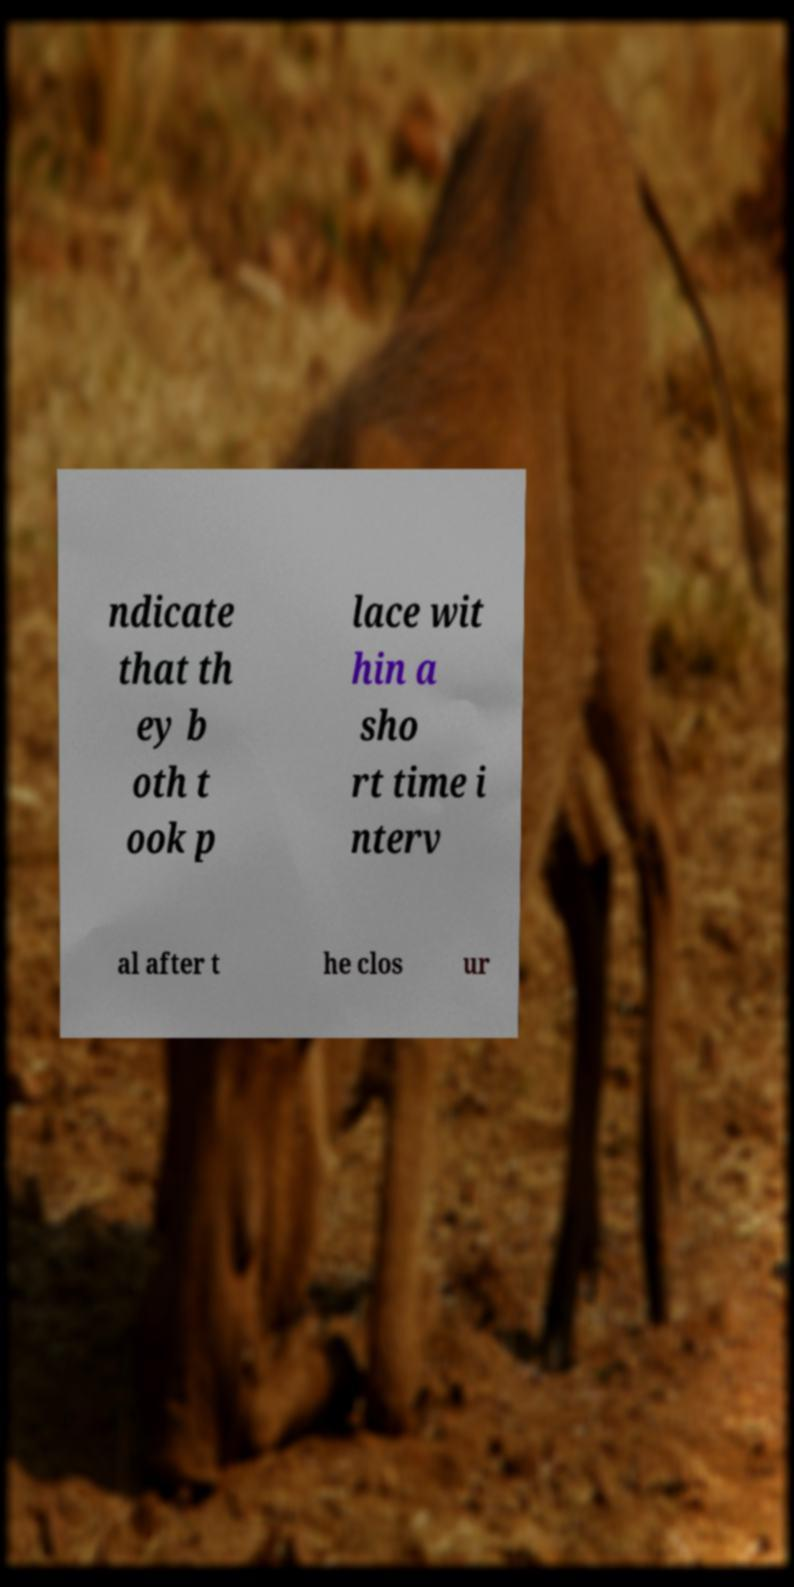There's text embedded in this image that I need extracted. Can you transcribe it verbatim? ndicate that th ey b oth t ook p lace wit hin a sho rt time i nterv al after t he clos ur 